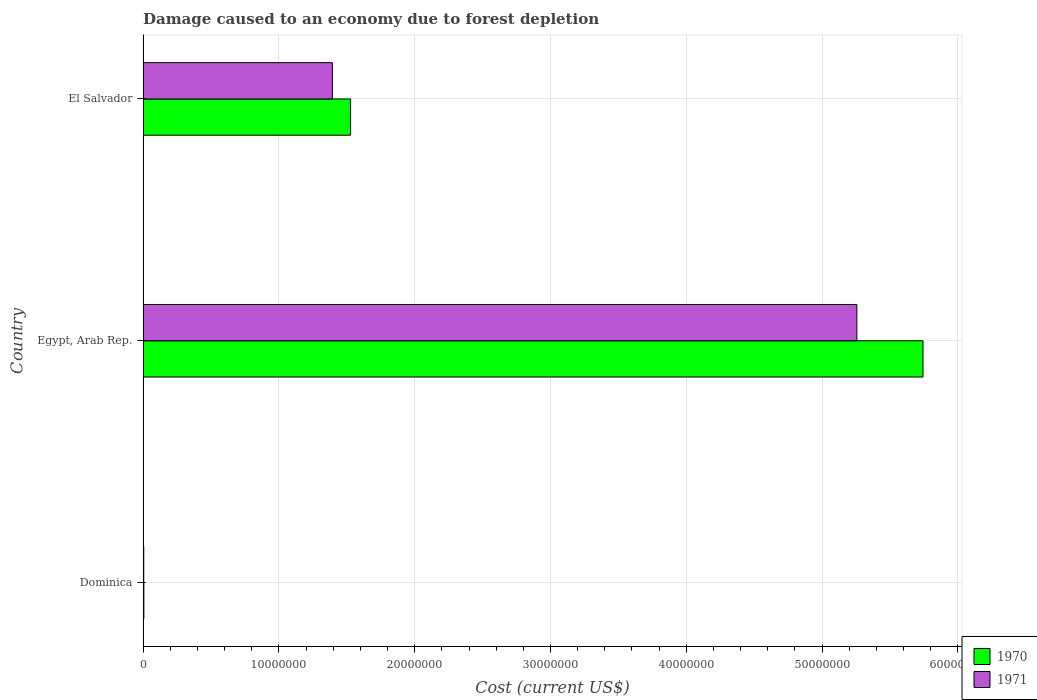Are the number of bars per tick equal to the number of legend labels?
Give a very brief answer. Yes. What is the label of the 1st group of bars from the top?
Make the answer very short. El Salvador. What is the cost of damage caused due to forest depletion in 1971 in Dominica?
Your response must be concise. 5.09e+04. Across all countries, what is the maximum cost of damage caused due to forest depletion in 1970?
Keep it short and to the point. 5.74e+07. Across all countries, what is the minimum cost of damage caused due to forest depletion in 1970?
Keep it short and to the point. 5.98e+04. In which country was the cost of damage caused due to forest depletion in 1970 maximum?
Ensure brevity in your answer.  Egypt, Arab Rep. In which country was the cost of damage caused due to forest depletion in 1970 minimum?
Your answer should be very brief. Dominica. What is the total cost of damage caused due to forest depletion in 1971 in the graph?
Make the answer very short. 6.66e+07. What is the difference between the cost of damage caused due to forest depletion in 1971 in Dominica and that in El Salvador?
Provide a succinct answer. -1.39e+07. What is the difference between the cost of damage caused due to forest depletion in 1971 in Egypt, Arab Rep. and the cost of damage caused due to forest depletion in 1970 in Dominica?
Ensure brevity in your answer.  5.25e+07. What is the average cost of damage caused due to forest depletion in 1971 per country?
Provide a short and direct response. 2.22e+07. What is the difference between the cost of damage caused due to forest depletion in 1971 and cost of damage caused due to forest depletion in 1970 in El Salvador?
Your response must be concise. -1.34e+06. What is the ratio of the cost of damage caused due to forest depletion in 1971 in Dominica to that in Egypt, Arab Rep.?
Your answer should be very brief. 0. Is the cost of damage caused due to forest depletion in 1971 in Dominica less than that in El Salvador?
Provide a succinct answer. Yes. Is the difference between the cost of damage caused due to forest depletion in 1971 in Dominica and El Salvador greater than the difference between the cost of damage caused due to forest depletion in 1970 in Dominica and El Salvador?
Make the answer very short. Yes. What is the difference between the highest and the second highest cost of damage caused due to forest depletion in 1971?
Your answer should be very brief. 3.86e+07. What is the difference between the highest and the lowest cost of damage caused due to forest depletion in 1970?
Ensure brevity in your answer.  5.74e+07. In how many countries, is the cost of damage caused due to forest depletion in 1970 greater than the average cost of damage caused due to forest depletion in 1970 taken over all countries?
Offer a terse response. 1. Is the sum of the cost of damage caused due to forest depletion in 1971 in Dominica and El Salvador greater than the maximum cost of damage caused due to forest depletion in 1970 across all countries?
Offer a terse response. No. What does the 2nd bar from the top in Egypt, Arab Rep. represents?
Offer a terse response. 1970. What does the 2nd bar from the bottom in Egypt, Arab Rep. represents?
Ensure brevity in your answer.  1971. How many bars are there?
Keep it short and to the point. 6. Are all the bars in the graph horizontal?
Give a very brief answer. Yes. Are the values on the major ticks of X-axis written in scientific E-notation?
Offer a terse response. No. Does the graph contain any zero values?
Your response must be concise. No. Does the graph contain grids?
Your answer should be compact. Yes. How many legend labels are there?
Give a very brief answer. 2. What is the title of the graph?
Provide a short and direct response. Damage caused to an economy due to forest depletion. Does "2005" appear as one of the legend labels in the graph?
Offer a terse response. No. What is the label or title of the X-axis?
Your response must be concise. Cost (current US$). What is the label or title of the Y-axis?
Offer a terse response. Country. What is the Cost (current US$) of 1970 in Dominica?
Keep it short and to the point. 5.98e+04. What is the Cost (current US$) in 1971 in Dominica?
Provide a short and direct response. 5.09e+04. What is the Cost (current US$) of 1970 in Egypt, Arab Rep.?
Provide a succinct answer. 5.74e+07. What is the Cost (current US$) of 1971 in Egypt, Arab Rep.?
Offer a terse response. 5.26e+07. What is the Cost (current US$) in 1970 in El Salvador?
Your answer should be compact. 1.53e+07. What is the Cost (current US$) in 1971 in El Salvador?
Offer a terse response. 1.39e+07. Across all countries, what is the maximum Cost (current US$) in 1970?
Your response must be concise. 5.74e+07. Across all countries, what is the maximum Cost (current US$) of 1971?
Your response must be concise. 5.26e+07. Across all countries, what is the minimum Cost (current US$) of 1970?
Your answer should be compact. 5.98e+04. Across all countries, what is the minimum Cost (current US$) in 1971?
Give a very brief answer. 5.09e+04. What is the total Cost (current US$) of 1970 in the graph?
Your answer should be very brief. 7.28e+07. What is the total Cost (current US$) of 1971 in the graph?
Provide a short and direct response. 6.66e+07. What is the difference between the Cost (current US$) of 1970 in Dominica and that in Egypt, Arab Rep.?
Offer a terse response. -5.74e+07. What is the difference between the Cost (current US$) of 1971 in Dominica and that in Egypt, Arab Rep.?
Make the answer very short. -5.25e+07. What is the difference between the Cost (current US$) in 1970 in Dominica and that in El Salvador?
Keep it short and to the point. -1.52e+07. What is the difference between the Cost (current US$) of 1971 in Dominica and that in El Salvador?
Provide a short and direct response. -1.39e+07. What is the difference between the Cost (current US$) of 1970 in Egypt, Arab Rep. and that in El Salvador?
Your response must be concise. 4.21e+07. What is the difference between the Cost (current US$) in 1971 in Egypt, Arab Rep. and that in El Salvador?
Give a very brief answer. 3.86e+07. What is the difference between the Cost (current US$) of 1970 in Dominica and the Cost (current US$) of 1971 in Egypt, Arab Rep.?
Your response must be concise. -5.25e+07. What is the difference between the Cost (current US$) of 1970 in Dominica and the Cost (current US$) of 1971 in El Salvador?
Provide a succinct answer. -1.39e+07. What is the difference between the Cost (current US$) of 1970 in Egypt, Arab Rep. and the Cost (current US$) of 1971 in El Salvador?
Your answer should be very brief. 4.35e+07. What is the average Cost (current US$) in 1970 per country?
Offer a very short reply. 2.43e+07. What is the average Cost (current US$) in 1971 per country?
Provide a short and direct response. 2.22e+07. What is the difference between the Cost (current US$) of 1970 and Cost (current US$) of 1971 in Dominica?
Keep it short and to the point. 8949.07. What is the difference between the Cost (current US$) of 1970 and Cost (current US$) of 1971 in Egypt, Arab Rep.?
Keep it short and to the point. 4.87e+06. What is the difference between the Cost (current US$) of 1970 and Cost (current US$) of 1971 in El Salvador?
Provide a short and direct response. 1.34e+06. What is the ratio of the Cost (current US$) in 1970 in Dominica to that in Egypt, Arab Rep.?
Your response must be concise. 0. What is the ratio of the Cost (current US$) in 1970 in Dominica to that in El Salvador?
Your response must be concise. 0. What is the ratio of the Cost (current US$) in 1971 in Dominica to that in El Salvador?
Your answer should be compact. 0. What is the ratio of the Cost (current US$) of 1970 in Egypt, Arab Rep. to that in El Salvador?
Provide a short and direct response. 3.76. What is the ratio of the Cost (current US$) in 1971 in Egypt, Arab Rep. to that in El Salvador?
Your answer should be very brief. 3.77. What is the difference between the highest and the second highest Cost (current US$) of 1970?
Make the answer very short. 4.21e+07. What is the difference between the highest and the second highest Cost (current US$) in 1971?
Make the answer very short. 3.86e+07. What is the difference between the highest and the lowest Cost (current US$) of 1970?
Offer a terse response. 5.74e+07. What is the difference between the highest and the lowest Cost (current US$) in 1971?
Provide a succinct answer. 5.25e+07. 